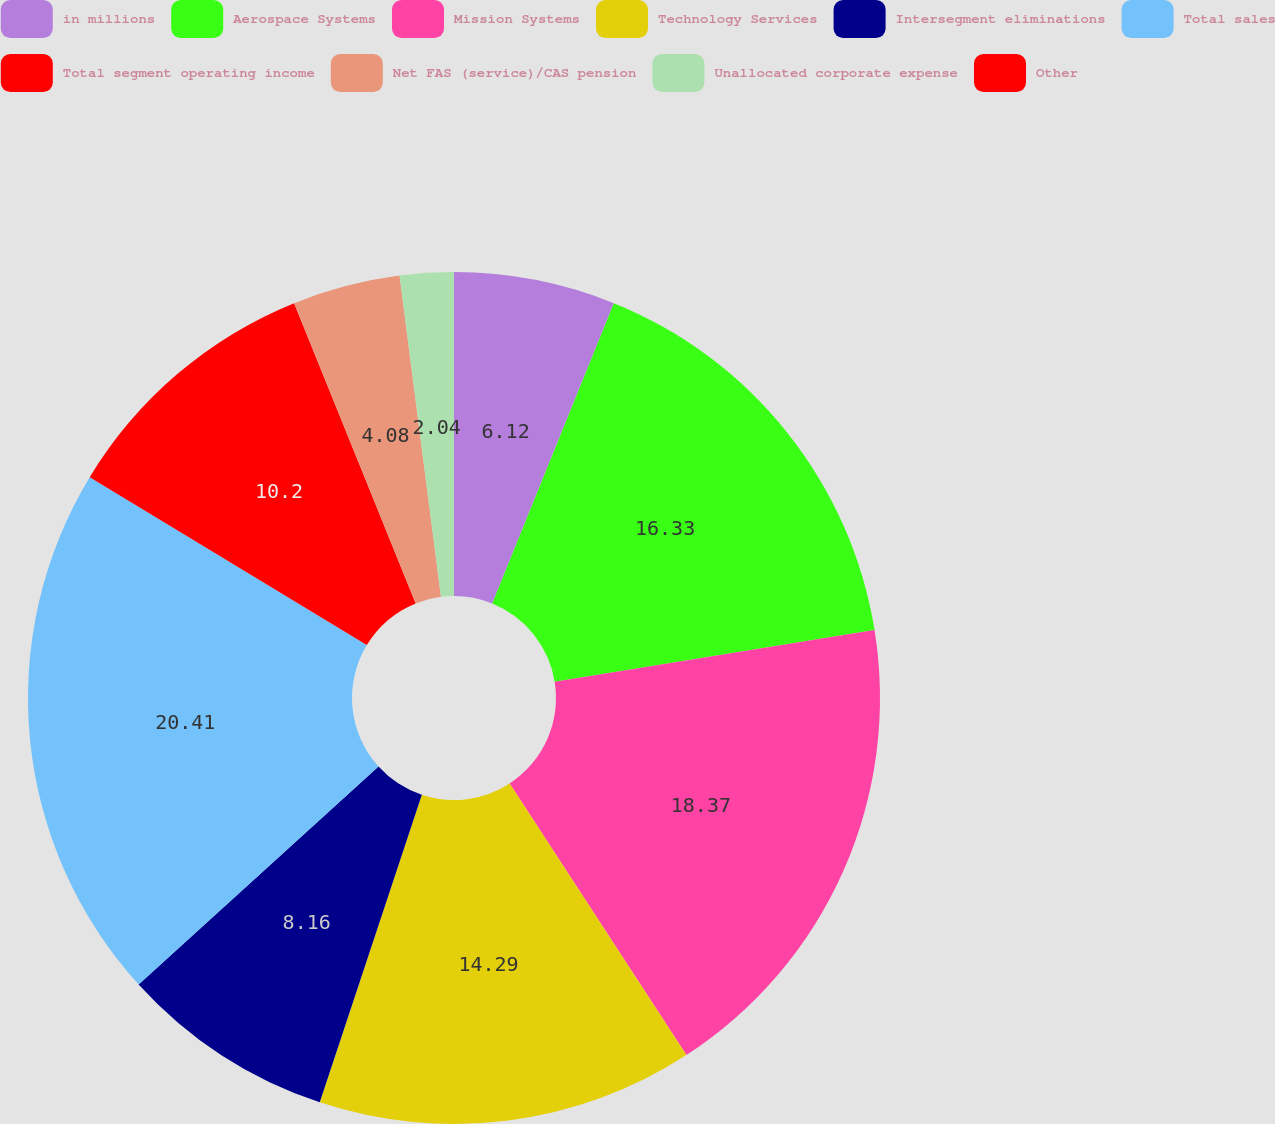<chart> <loc_0><loc_0><loc_500><loc_500><pie_chart><fcel>in millions<fcel>Aerospace Systems<fcel>Mission Systems<fcel>Technology Services<fcel>Intersegment eliminations<fcel>Total sales<fcel>Total segment operating income<fcel>Net FAS (service)/CAS pension<fcel>Unallocated corporate expense<fcel>Other<nl><fcel>6.12%<fcel>16.32%<fcel>18.36%<fcel>14.28%<fcel>8.16%<fcel>20.4%<fcel>10.2%<fcel>4.08%<fcel>2.04%<fcel>0.0%<nl></chart> 